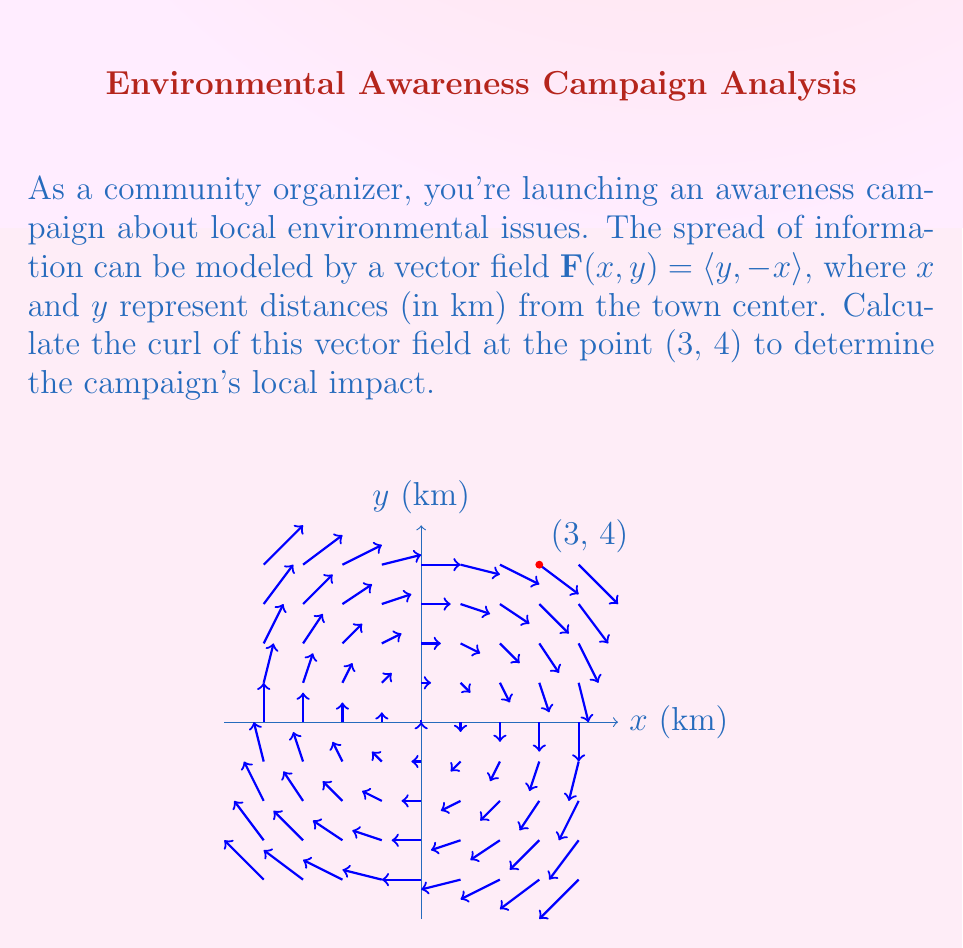Give your solution to this math problem. To solve this problem, we need to follow these steps:

1) The curl of a vector field $\mathbf{F}(x,y) = \langle P, Q \rangle$ in two dimensions is given by:

   $$\text{curl }\mathbf{F} = \frac{\partial Q}{\partial x} - \frac{\partial P}{\partial y}$$

2) In our case, $\mathbf{F}(x,y) = \langle y, -x \rangle$, so $P = y$ and $Q = -x$.

3) Let's calculate the partial derivatives:
   
   $\frac{\partial Q}{\partial x} = \frac{\partial}{\partial x}(-x) = -1$
   
   $\frac{\partial P}{\partial y} = \frac{\partial}{\partial y}(y) = 1$

4) Now we can substitute these into the curl formula:

   $$\text{curl }\mathbf{F} = \frac{\partial Q}{\partial x} - \frac{\partial P}{\partial y} = -1 - 1 = -2$$

5) This result is constant and doesn't depend on $x$ or $y$, so it's the same at all points, including (3, 4).

The negative curl indicates that the campaign information is spreading in a clockwise direction around each point, with a magnitude of 2 units per square kilometer.
Answer: $-2$ 